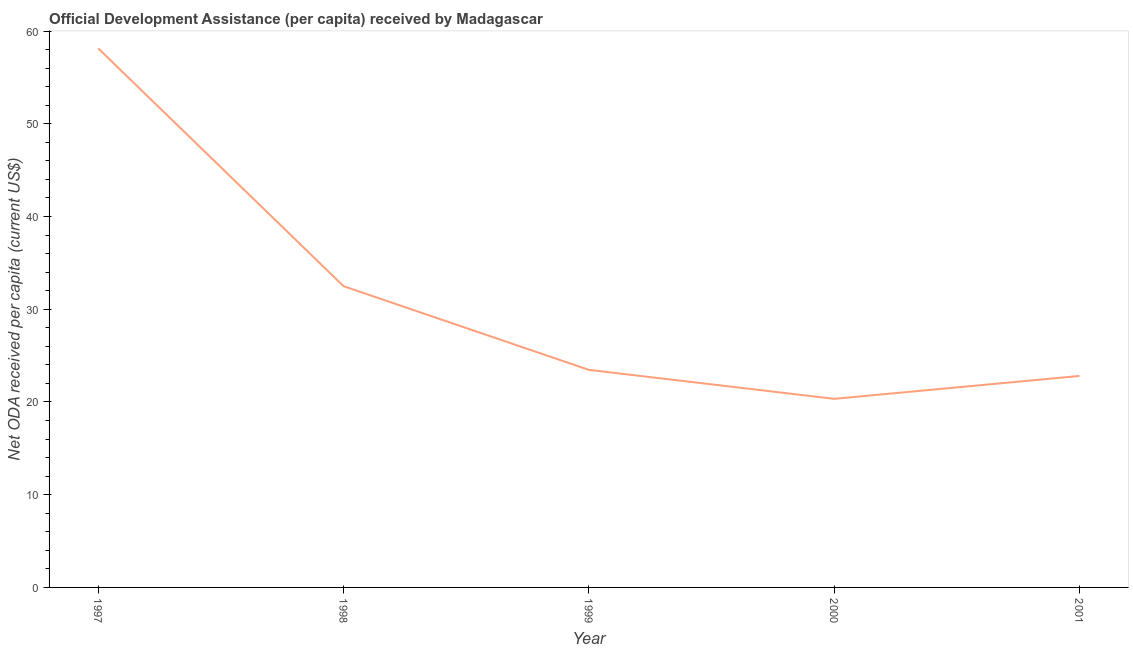What is the net oda received per capita in 1999?
Your response must be concise. 23.46. Across all years, what is the maximum net oda received per capita?
Give a very brief answer. 58.13. Across all years, what is the minimum net oda received per capita?
Your answer should be very brief. 20.34. In which year was the net oda received per capita minimum?
Provide a succinct answer. 2000. What is the sum of the net oda received per capita?
Offer a terse response. 157.22. What is the difference between the net oda received per capita in 1997 and 2001?
Offer a very short reply. 35.33. What is the average net oda received per capita per year?
Keep it short and to the point. 31.44. What is the median net oda received per capita?
Provide a succinct answer. 23.46. What is the ratio of the net oda received per capita in 1998 to that in 1999?
Give a very brief answer. 1.38. Is the net oda received per capita in 1997 less than that in 2000?
Offer a very short reply. No. What is the difference between the highest and the second highest net oda received per capita?
Your answer should be very brief. 25.65. Is the sum of the net oda received per capita in 1997 and 2000 greater than the maximum net oda received per capita across all years?
Offer a terse response. Yes. What is the difference between the highest and the lowest net oda received per capita?
Keep it short and to the point. 37.8. Does the graph contain grids?
Keep it short and to the point. No. What is the title of the graph?
Your response must be concise. Official Development Assistance (per capita) received by Madagascar. What is the label or title of the X-axis?
Your answer should be compact. Year. What is the label or title of the Y-axis?
Keep it short and to the point. Net ODA received per capita (current US$). What is the Net ODA received per capita (current US$) in 1997?
Keep it short and to the point. 58.13. What is the Net ODA received per capita (current US$) in 1998?
Ensure brevity in your answer.  32.49. What is the Net ODA received per capita (current US$) in 1999?
Your response must be concise. 23.46. What is the Net ODA received per capita (current US$) of 2000?
Offer a very short reply. 20.34. What is the Net ODA received per capita (current US$) in 2001?
Keep it short and to the point. 22.8. What is the difference between the Net ODA received per capita (current US$) in 1997 and 1998?
Your answer should be compact. 25.65. What is the difference between the Net ODA received per capita (current US$) in 1997 and 1999?
Provide a succinct answer. 34.67. What is the difference between the Net ODA received per capita (current US$) in 1997 and 2000?
Your answer should be compact. 37.8. What is the difference between the Net ODA received per capita (current US$) in 1997 and 2001?
Make the answer very short. 35.33. What is the difference between the Net ODA received per capita (current US$) in 1998 and 1999?
Give a very brief answer. 9.03. What is the difference between the Net ODA received per capita (current US$) in 1998 and 2000?
Offer a terse response. 12.15. What is the difference between the Net ODA received per capita (current US$) in 1998 and 2001?
Ensure brevity in your answer.  9.68. What is the difference between the Net ODA received per capita (current US$) in 1999 and 2000?
Provide a short and direct response. 3.13. What is the difference between the Net ODA received per capita (current US$) in 1999 and 2001?
Give a very brief answer. 0.66. What is the difference between the Net ODA received per capita (current US$) in 2000 and 2001?
Your answer should be compact. -2.47. What is the ratio of the Net ODA received per capita (current US$) in 1997 to that in 1998?
Ensure brevity in your answer.  1.79. What is the ratio of the Net ODA received per capita (current US$) in 1997 to that in 1999?
Make the answer very short. 2.48. What is the ratio of the Net ODA received per capita (current US$) in 1997 to that in 2000?
Ensure brevity in your answer.  2.86. What is the ratio of the Net ODA received per capita (current US$) in 1997 to that in 2001?
Keep it short and to the point. 2.55. What is the ratio of the Net ODA received per capita (current US$) in 1998 to that in 1999?
Give a very brief answer. 1.39. What is the ratio of the Net ODA received per capita (current US$) in 1998 to that in 2000?
Provide a short and direct response. 1.6. What is the ratio of the Net ODA received per capita (current US$) in 1998 to that in 2001?
Keep it short and to the point. 1.43. What is the ratio of the Net ODA received per capita (current US$) in 1999 to that in 2000?
Provide a succinct answer. 1.15. What is the ratio of the Net ODA received per capita (current US$) in 1999 to that in 2001?
Ensure brevity in your answer.  1.03. What is the ratio of the Net ODA received per capita (current US$) in 2000 to that in 2001?
Keep it short and to the point. 0.89. 